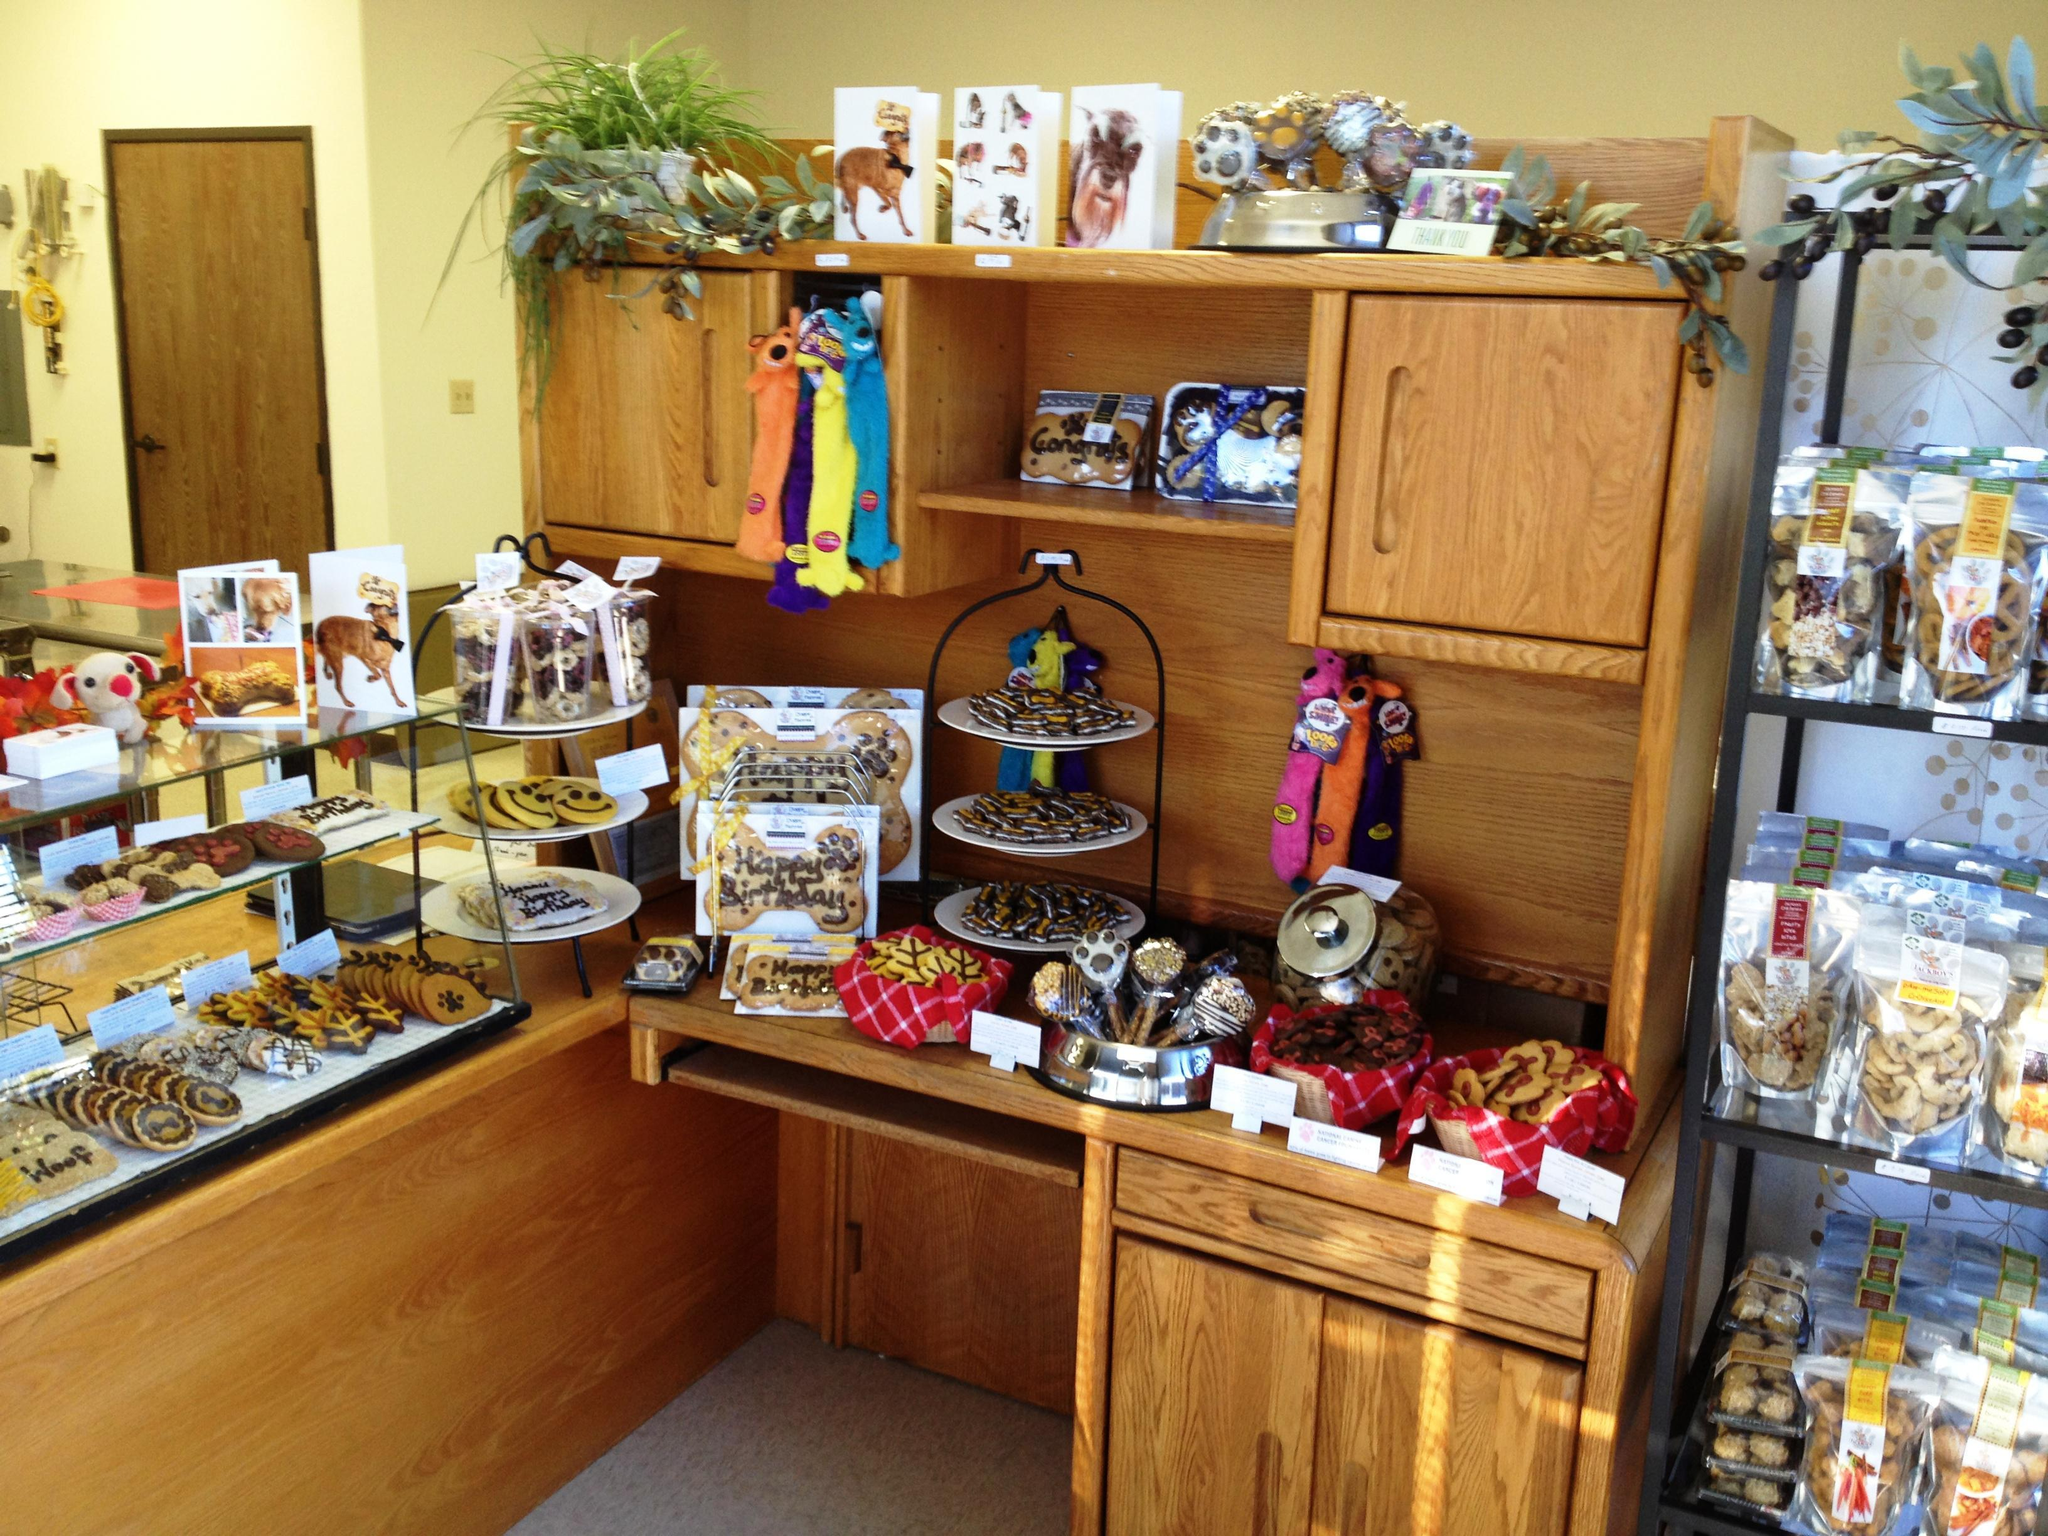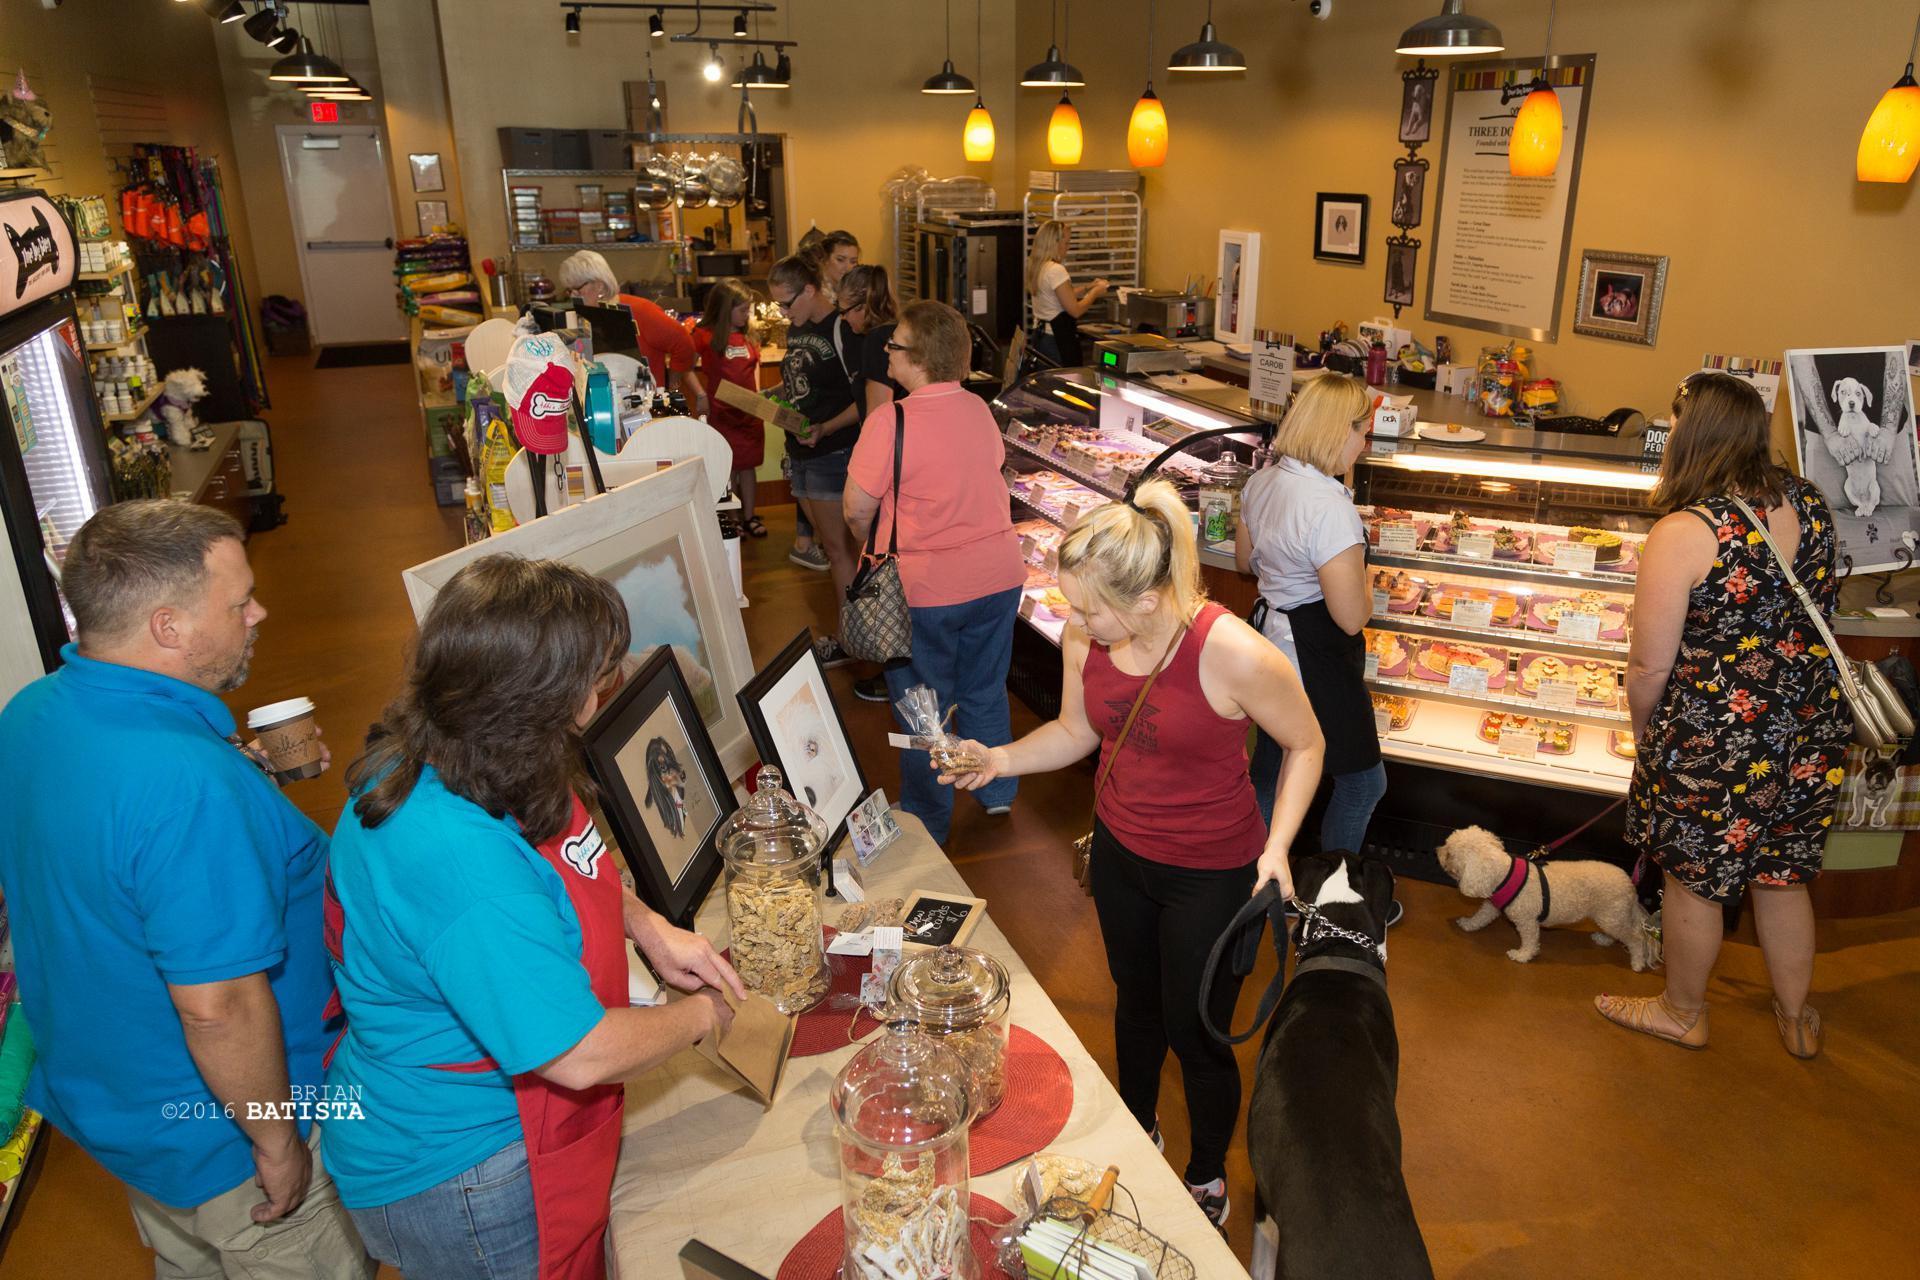The first image is the image on the left, the second image is the image on the right. Analyze the images presented: Is the assertion "A dog has its front paws on the counter in the image on the right." valid? Answer yes or no. No. The first image is the image on the left, the second image is the image on the right. For the images displayed, is the sentence "An image shows a golden-haired right-facing dog standing with its front paws propped atop a wood-front counter." factually correct? Answer yes or no. No. 